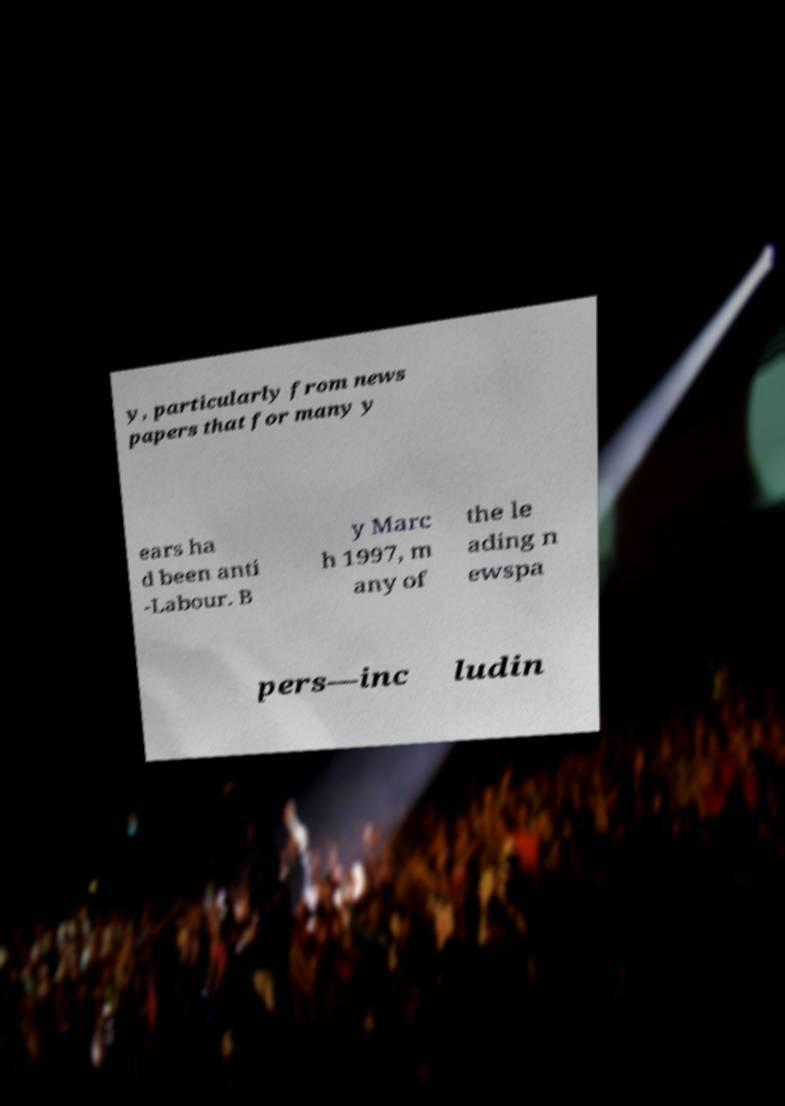I need the written content from this picture converted into text. Can you do that? y, particularly from news papers that for many y ears ha d been anti -Labour. B y Marc h 1997, m any of the le ading n ewspa pers—inc ludin 